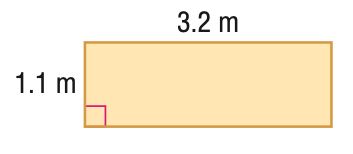Answer the mathemtical geometry problem and directly provide the correct option letter.
Question: Find the area of the figure. Round to the nearest tenth.
Choices: A: 1.2 B: 3.5 C: 8.6 D: 10.2 B 